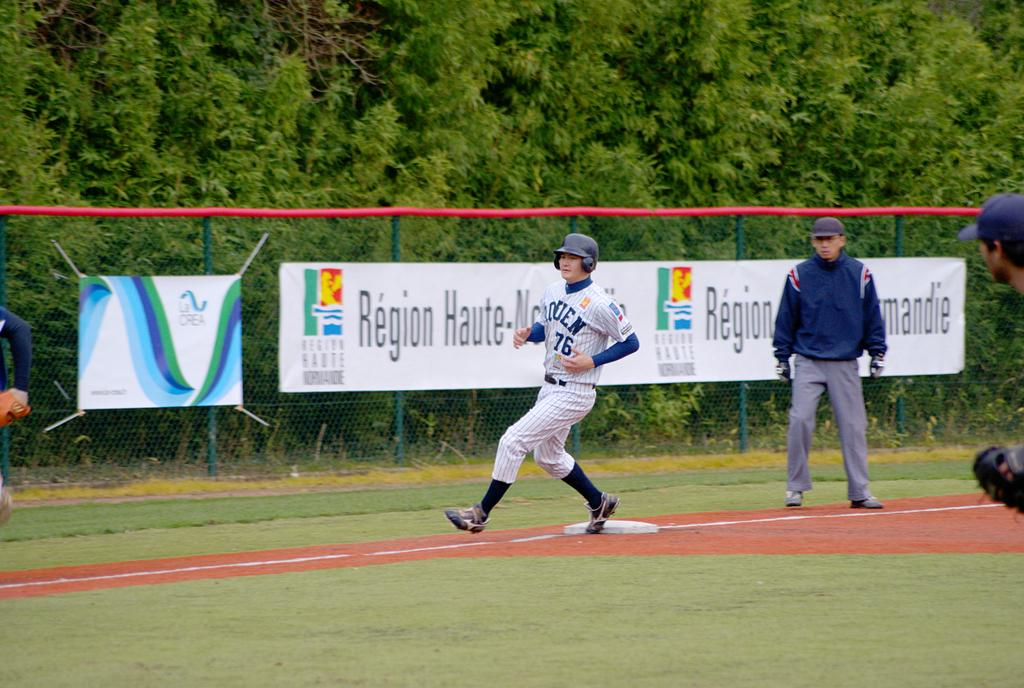Provide a one-sentence caption for the provided image. Number 76 is shown on the jersey of the player rounding the bases. 